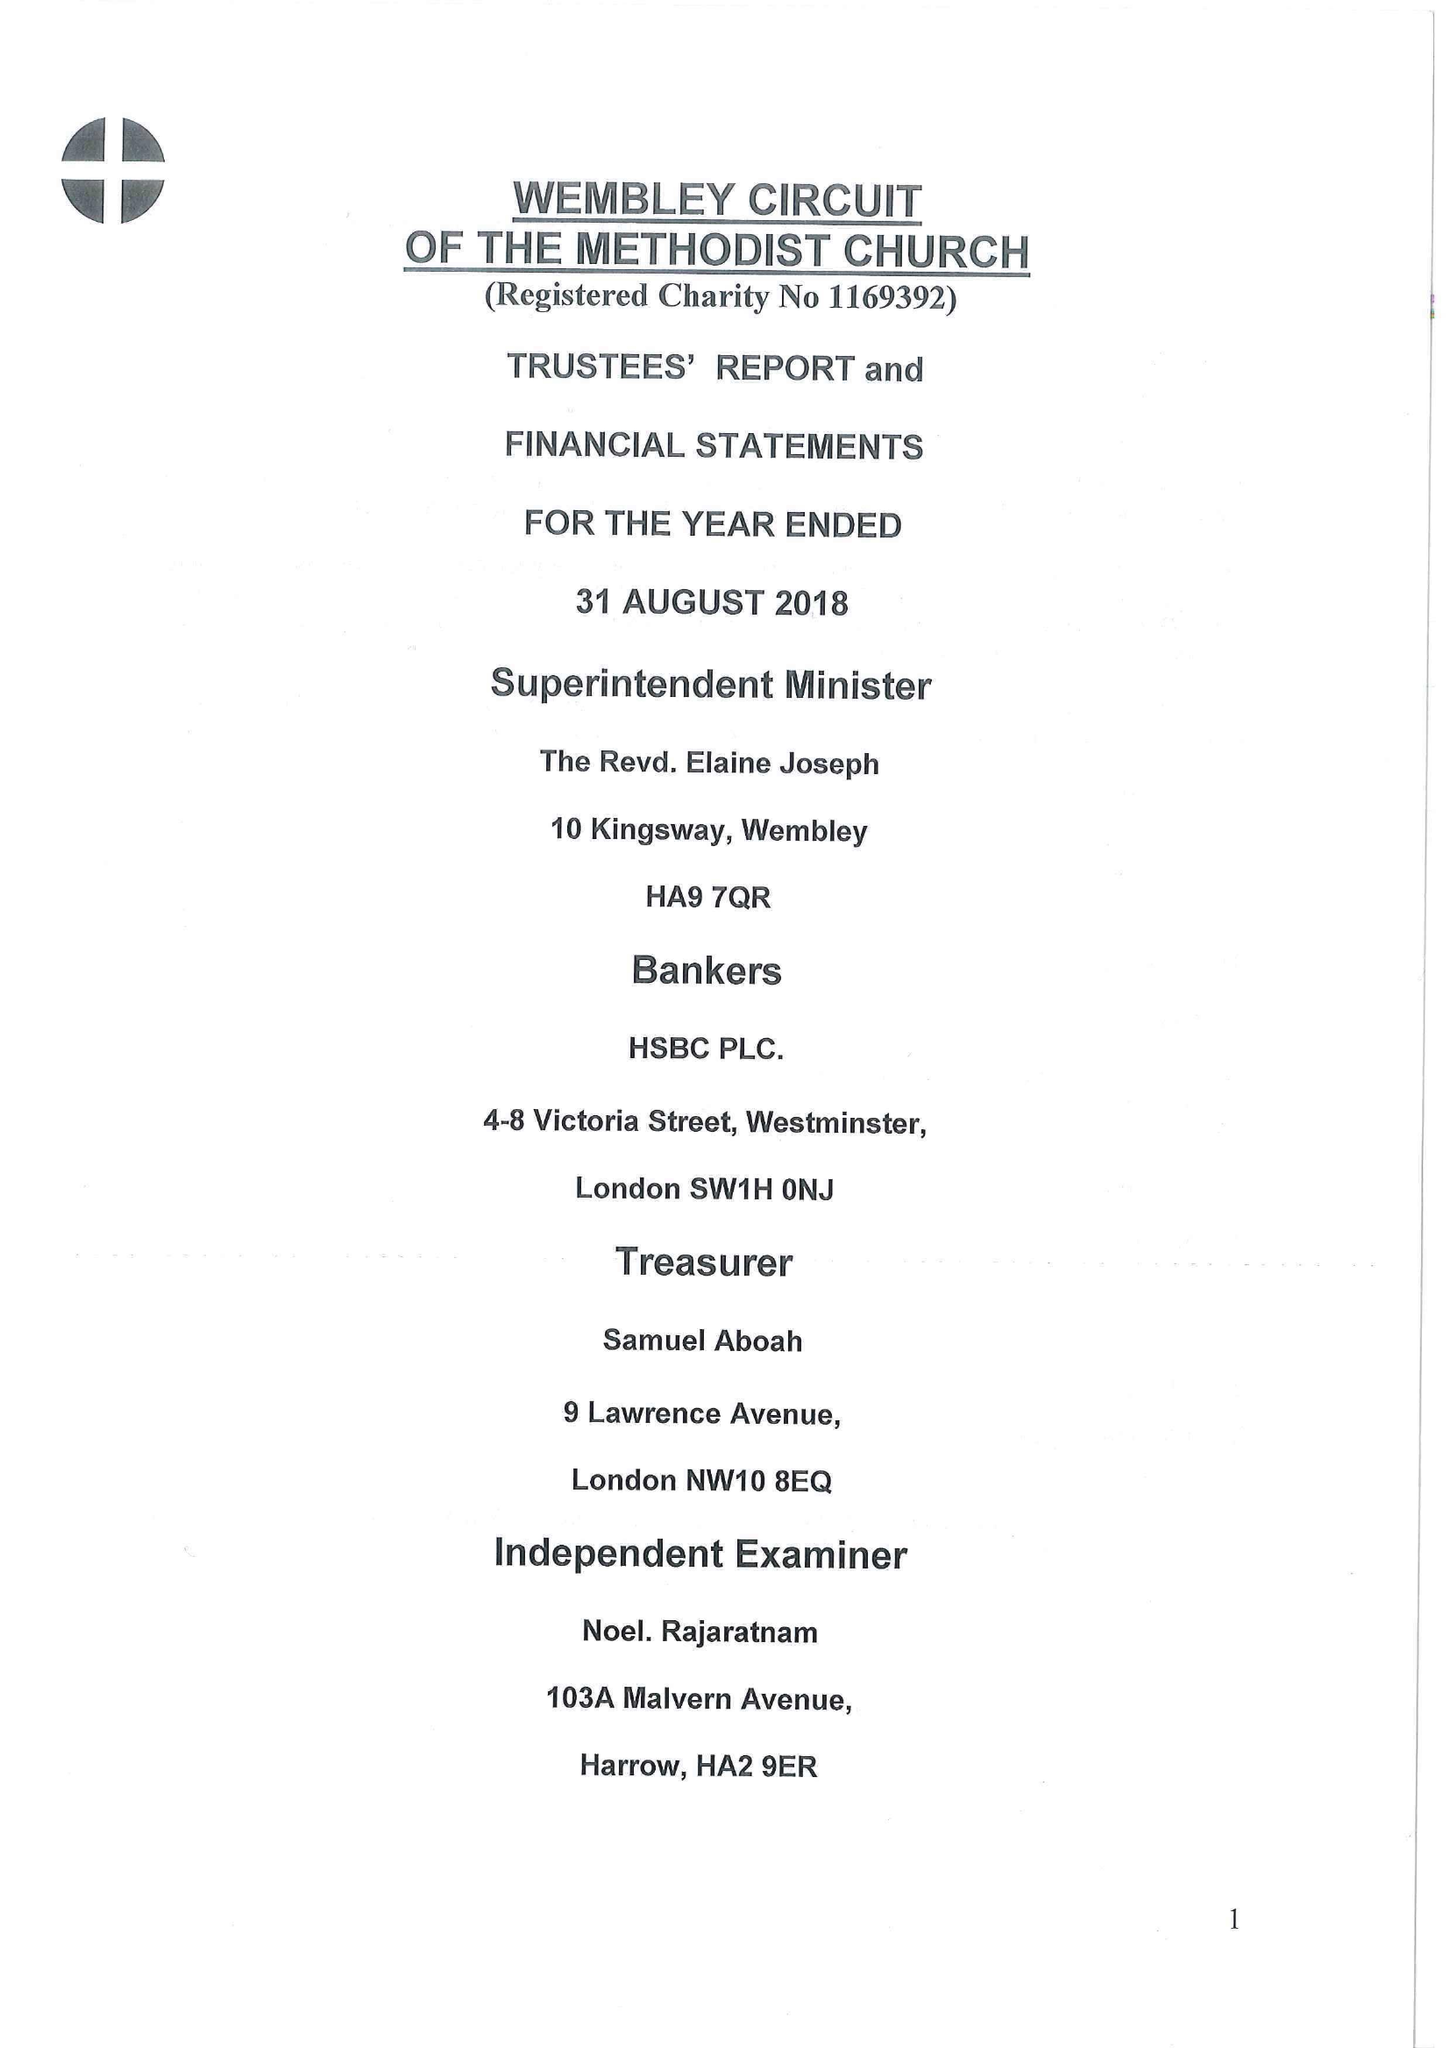What is the value for the address__postcode?
Answer the question using a single word or phrase. HA9 7QR 